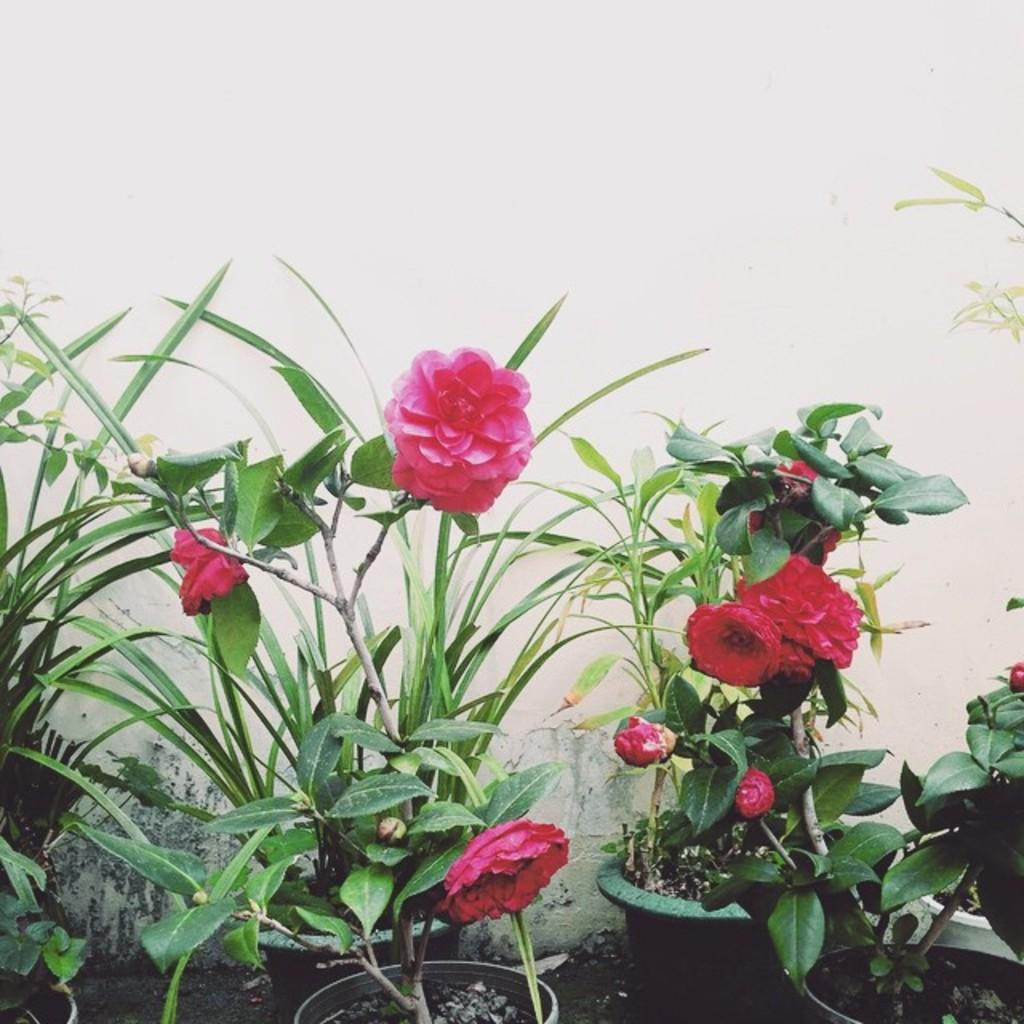What type of plants can be seen in the image? There are flowers in the image. What are the flowers placed in? There are flower pots in the image. What is the background of the image? There is a wall in the image. What is the effect of the low temperature on the flowers in the image? There is no information about the temperature in the image, and therefore no such effect can be observed. 